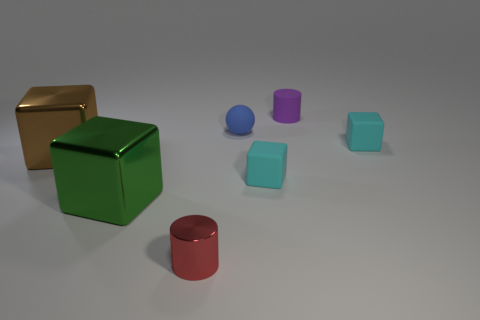Subtract 1 cubes. How many cubes are left? 3 Add 1 large brown metal things. How many objects exist? 8 Subtract all cubes. How many objects are left? 3 Add 3 big brown cubes. How many big brown cubes exist? 4 Subtract 0 yellow cylinders. How many objects are left? 7 Subtract all tiny blue rubber things. Subtract all big things. How many objects are left? 4 Add 7 rubber balls. How many rubber balls are left? 8 